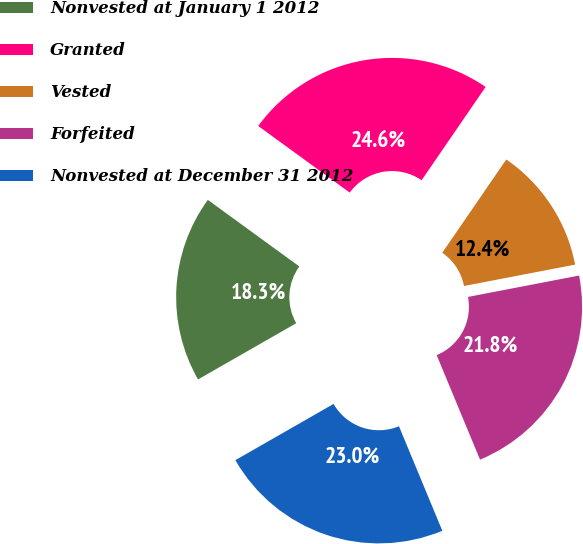Convert chart. <chart><loc_0><loc_0><loc_500><loc_500><pie_chart><fcel>Nonvested at January 1 2012<fcel>Granted<fcel>Vested<fcel>Forfeited<fcel>Nonvested at December 31 2012<nl><fcel>18.29%<fcel>24.56%<fcel>12.4%<fcel>21.77%<fcel>22.98%<nl></chart> 